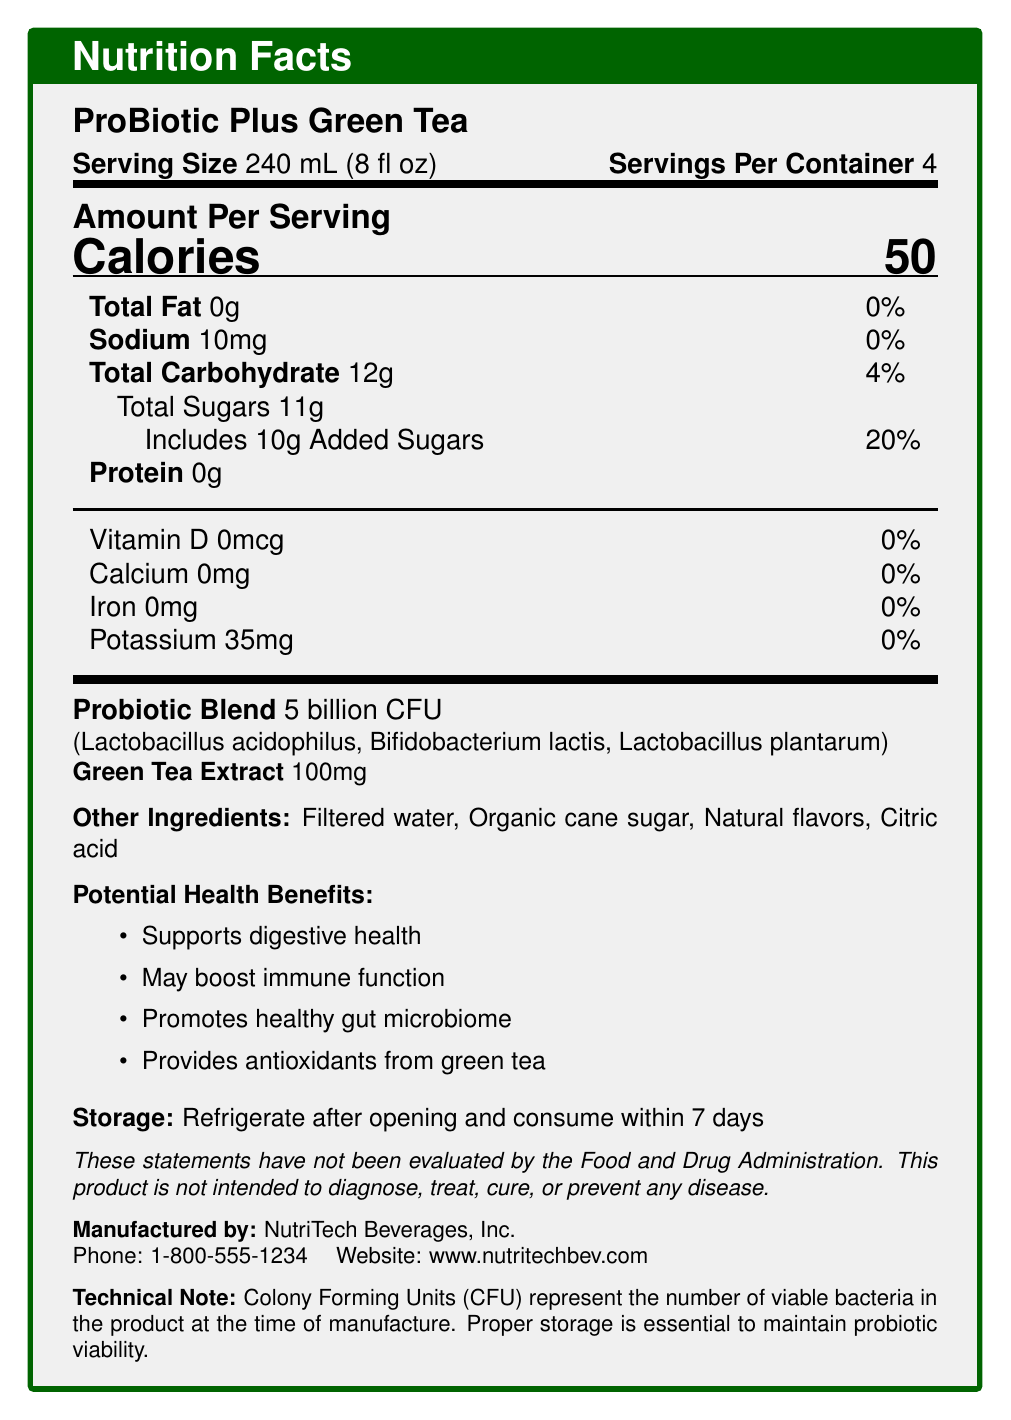What is the serving size for ProBiotic Plus Green Tea? The document states that the serving size is 240 mL (8 fl oz).
Answer: 240 mL (8 fl oz) How many calories are there per serving? The document lists the amount of calories per serving as 50.
Answer: 50 What is the total carbohydrate content per serving? According to the document, the total carbohydrate per serving is 12g.
Answer: 12g Name one probiotic strain included in ProBiotic Plus Green Tea. The probiotic blend includes Lactobacillus acidophilus, along with other strains.
Answer: Lactobacillus acidophilus What should you do after opening the product? The storage instructions specify to refrigerate the product after opening and consume it within 7 days.
Answer: Refrigerate and consume within 7 days Which of the following is NOT listed as a potential health benefit? A. Supports digestive health B. Enhances muscle growth C. May boost immune function D. Provides antioxidants from green tea The document lists "Supports digestive health," "May boost immune function," and "Provides antioxidants from green tea" as potential health benefits, but not "Enhances muscle growth."
Answer: B. Enhances muscle growth How much added sugar is there per serving? A. 1g B. 5g C. 10g D. 11g The document specifies that there are 10g of added sugars per serving.
Answer: C. 10g Is the product's sodium content significant? The document indicates that the sodium content is 10mg per serving, which is 0% of the daily value, making it insignificant.
Answer: No Briefly summarize the main idea of the document. The document provides detailed nutritional information, health benefits, ingredients, and storage instructions for ProBiotic Plus Green Tea.
Answer: ProBiotic Plus Green Tea is a functional food product containing probiotics and green tea extract. Each serving (240 mL) has 50 calories, 0g fat, 10mg sodium, and 12g carbohydrates. The product promises several health benefits, including digestive support and antioxidant provision. It should be refrigerated after opening and consumed within 7 days. Who is the manufacturer of ProBiotic Plus Green Tea? The document states that the product is manufactured by NutriTech Beverages, Inc.
Answer: NutriTech Beverages, Inc. What is the daily value percentage for calcium in this product? The document mentions that the calcium content is 0mg, which is 0% of the daily value.
Answer: 0% What is the recommended storage method for this product? The storage instructions are to refrigerate the product after opening.
Answer: Refrigerate after opening What kind of sugar is used in the product? The other ingredients list includes organic cane sugar.
Answer: Organic cane sugar How many servings are provided per container? The document states there are 4 servings per container of ProBiotic Plus Green Tea.
Answer: 4 What is the green tea extract content per serving? The document specifies that there is 100mg of green tea extract per serving.
Answer: 100mg Can you determine the exact number of grams of protein in the entire container? The document provides the protein content per serving (0g), but does not specify the total protein content for the entire container.
Answer: Not enough information What is the significance of the Colony Forming Units (CFU) mentioned in the document? The technical note explains the importance of CFUs in indicating the number of viable probiotic bacteria in the product and the need for appropriate storage to maintain their viability.
Answer: CFUs represent the number of viable bacteria in the product at the time of manufacture. Proper storage is essential to maintain probiotic viability. 